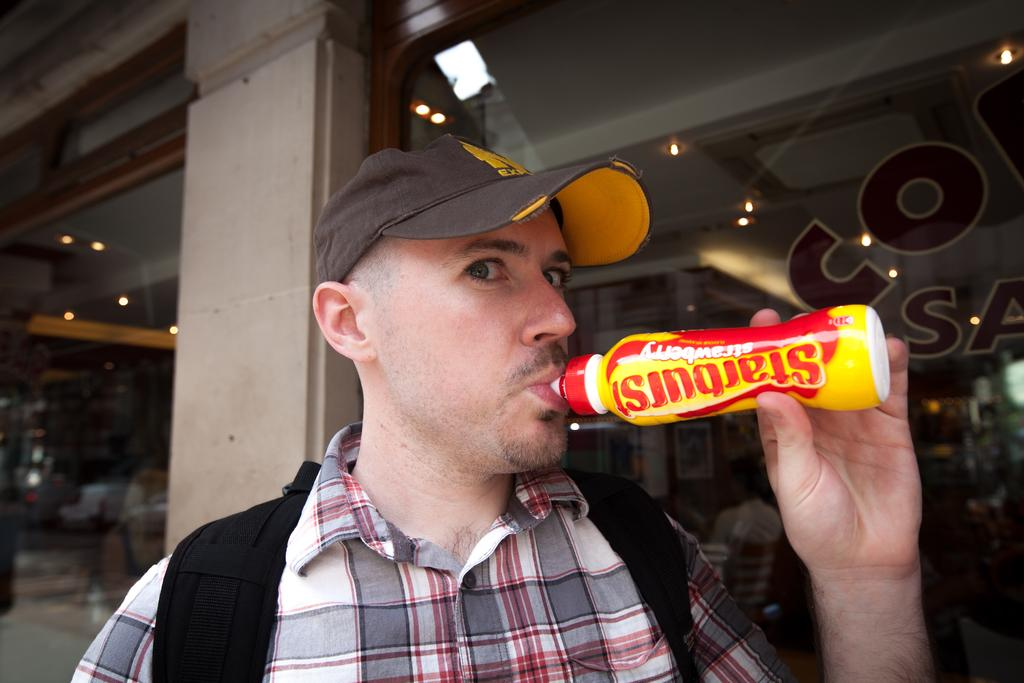Who is present in the image? There is a man in the image. What is the man doing in the image? The man is drinking something. What objects can be seen behind the man? There are two glasses behind the man. What separates the glasses in the image? There is a wall between the glasses. What is the profit margin of the man in the image? There is no information about profit margins in the image, as it only shows a man drinking something and two glasses behind him. 